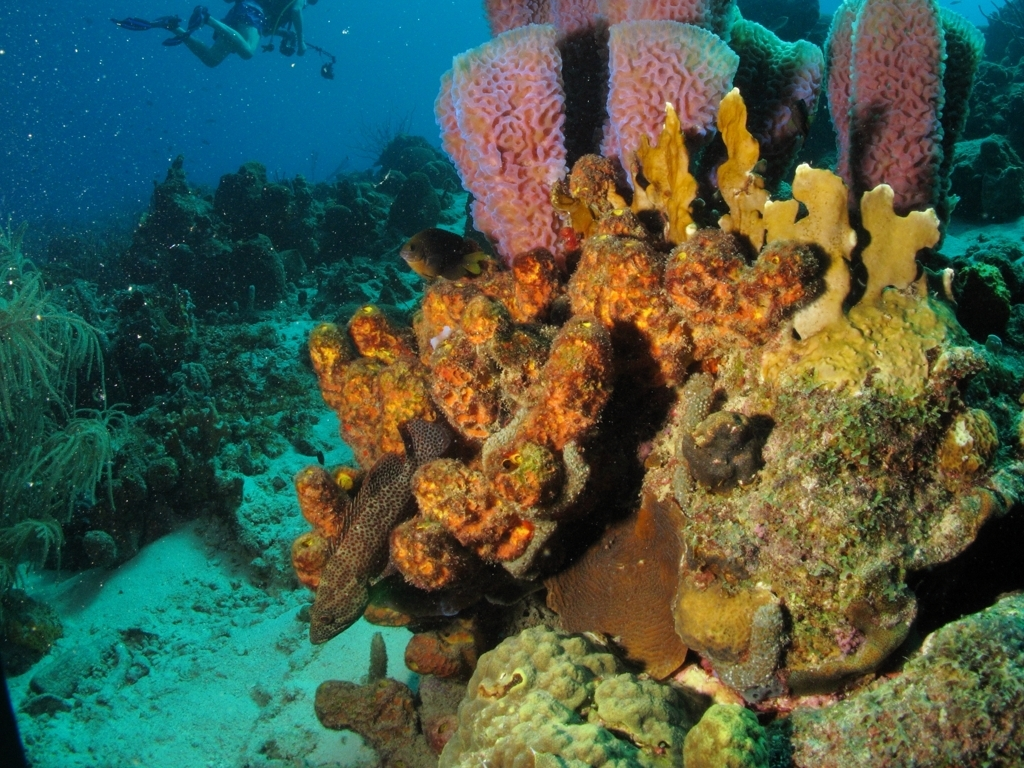Is there any marine life visible other than the coral? Yes, there is marine life besides the corals. If you look closely, there's a fish camouflaged against the coral in the center, likely a type of grouper with its spotted skin assisting in its stealth. The surrounding sandy areas and the water column likely host a variety of other marine creatures, although they may not be visible in this still image. 